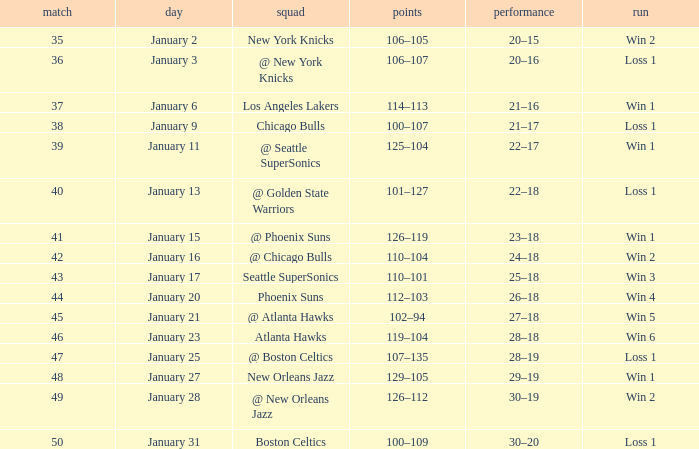What is the Team on January 20? Phoenix Suns. 